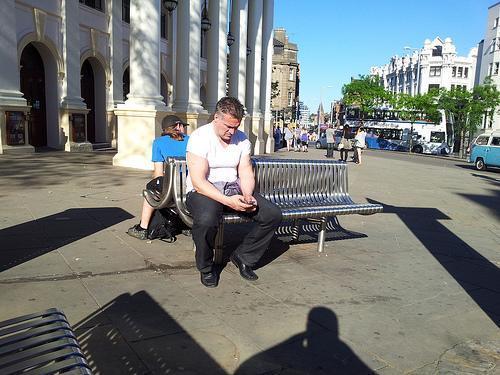How many people are sitting on a bench?
Give a very brief answer. 2. 